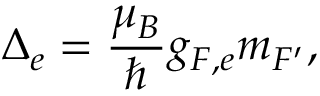<formula> <loc_0><loc_0><loc_500><loc_500>\Delta _ { e } = \frac { \mu _ { B } } { } g _ { F , e } m _ { F ^ { \prime } } ,</formula> 